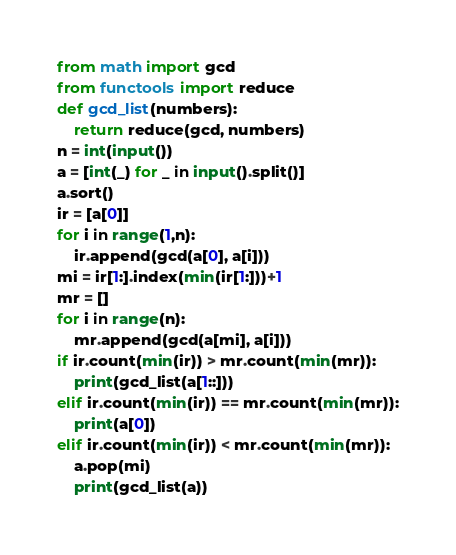<code> <loc_0><loc_0><loc_500><loc_500><_Python_>from math import gcd
from functools import reduce
def gcd_list(numbers):
    return reduce(gcd, numbers)
n = int(input())
a = [int(_) for _ in input().split()]
a.sort()
ir = [a[0]]
for i in range(1,n):
    ir.append(gcd(a[0], a[i]))
mi = ir[1:].index(min(ir[1:]))+1
mr = []
for i in range(n):
    mr.append(gcd(a[mi], a[i]))
if ir.count(min(ir)) > mr.count(min(mr)):
    print(gcd_list(a[1::]))
elif ir.count(min(ir)) == mr.count(min(mr)):
    print(a[0])
elif ir.count(min(ir)) < mr.count(min(mr)):
    a.pop(mi)
    print(gcd_list(a))
</code> 